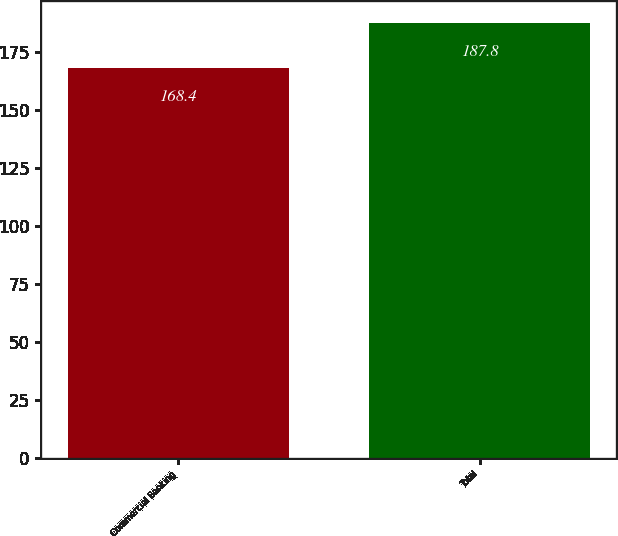Convert chart. <chart><loc_0><loc_0><loc_500><loc_500><bar_chart><fcel>Commercial Banking<fcel>Total<nl><fcel>168.4<fcel>187.8<nl></chart> 